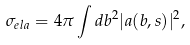<formula> <loc_0><loc_0><loc_500><loc_500>\sigma _ { e l a } = 4 \pi \int d b ^ { 2 } | a ( { b } , s ) | ^ { 2 } ,</formula> 